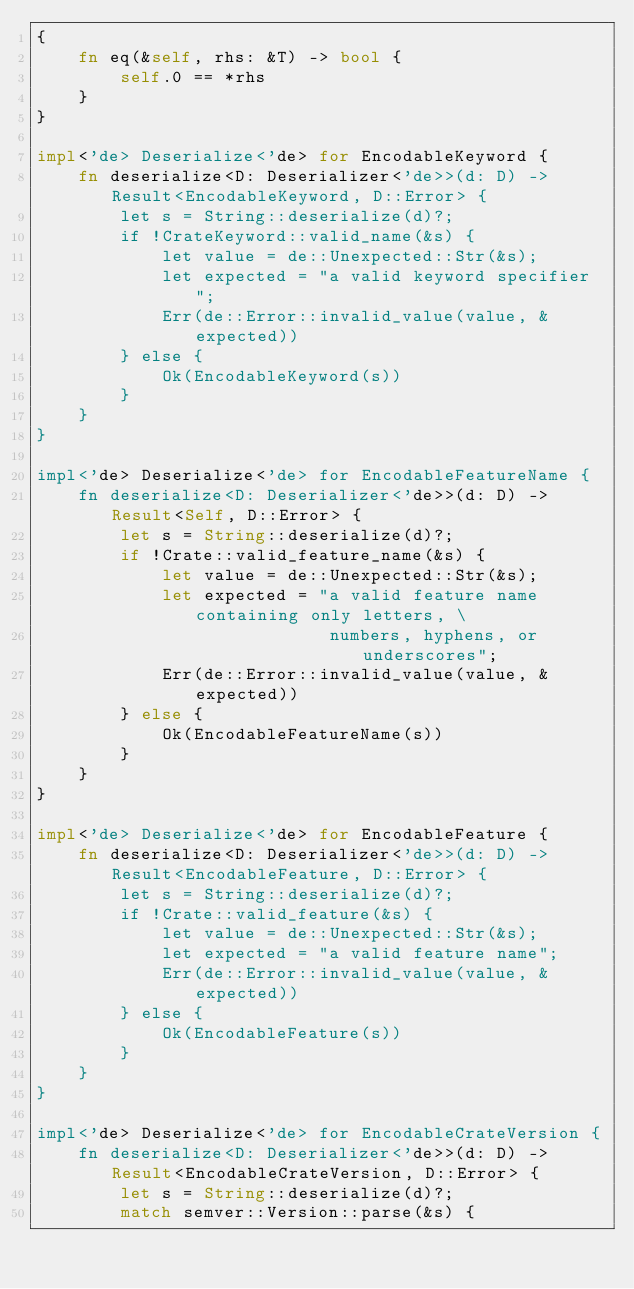<code> <loc_0><loc_0><loc_500><loc_500><_Rust_>{
    fn eq(&self, rhs: &T) -> bool {
        self.0 == *rhs
    }
}

impl<'de> Deserialize<'de> for EncodableKeyword {
    fn deserialize<D: Deserializer<'de>>(d: D) -> Result<EncodableKeyword, D::Error> {
        let s = String::deserialize(d)?;
        if !CrateKeyword::valid_name(&s) {
            let value = de::Unexpected::Str(&s);
            let expected = "a valid keyword specifier";
            Err(de::Error::invalid_value(value, &expected))
        } else {
            Ok(EncodableKeyword(s))
        }
    }
}

impl<'de> Deserialize<'de> for EncodableFeatureName {
    fn deserialize<D: Deserializer<'de>>(d: D) -> Result<Self, D::Error> {
        let s = String::deserialize(d)?;
        if !Crate::valid_feature_name(&s) {
            let value = de::Unexpected::Str(&s);
            let expected = "a valid feature name containing only letters, \
                            numbers, hyphens, or underscores";
            Err(de::Error::invalid_value(value, &expected))
        } else {
            Ok(EncodableFeatureName(s))
        }
    }
}

impl<'de> Deserialize<'de> for EncodableFeature {
    fn deserialize<D: Deserializer<'de>>(d: D) -> Result<EncodableFeature, D::Error> {
        let s = String::deserialize(d)?;
        if !Crate::valid_feature(&s) {
            let value = de::Unexpected::Str(&s);
            let expected = "a valid feature name";
            Err(de::Error::invalid_value(value, &expected))
        } else {
            Ok(EncodableFeature(s))
        }
    }
}

impl<'de> Deserialize<'de> for EncodableCrateVersion {
    fn deserialize<D: Deserializer<'de>>(d: D) -> Result<EncodableCrateVersion, D::Error> {
        let s = String::deserialize(d)?;
        match semver::Version::parse(&s) {</code> 